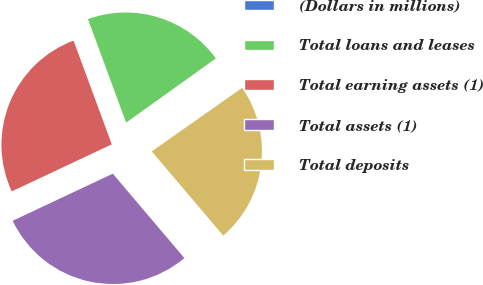Convert chart. <chart><loc_0><loc_0><loc_500><loc_500><pie_chart><fcel>(Dollars in millions)<fcel>Total loans and leases<fcel>Total earning assets (1)<fcel>Total assets (1)<fcel>Total deposits<nl><fcel>0.13%<fcel>20.74%<fcel>26.38%<fcel>29.2%<fcel>23.56%<nl></chart> 